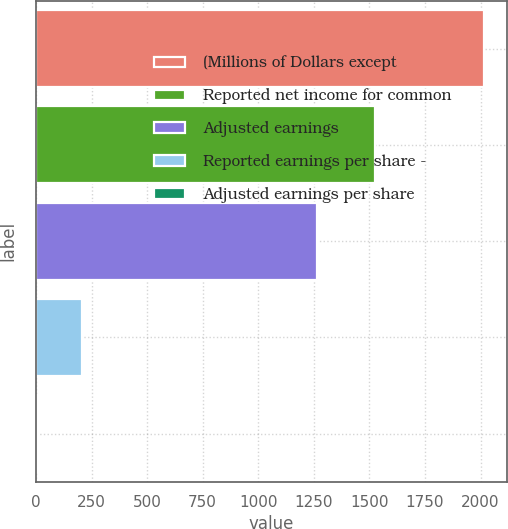Convert chart. <chart><loc_0><loc_0><loc_500><loc_500><bar_chart><fcel>(Millions of Dollars except<fcel>Reported net income for common<fcel>Adjusted earnings<fcel>Reported earnings per share -<fcel>Adjusted earnings per share<nl><fcel>2017<fcel>1525<fcel>1264<fcel>205.41<fcel>4.12<nl></chart> 